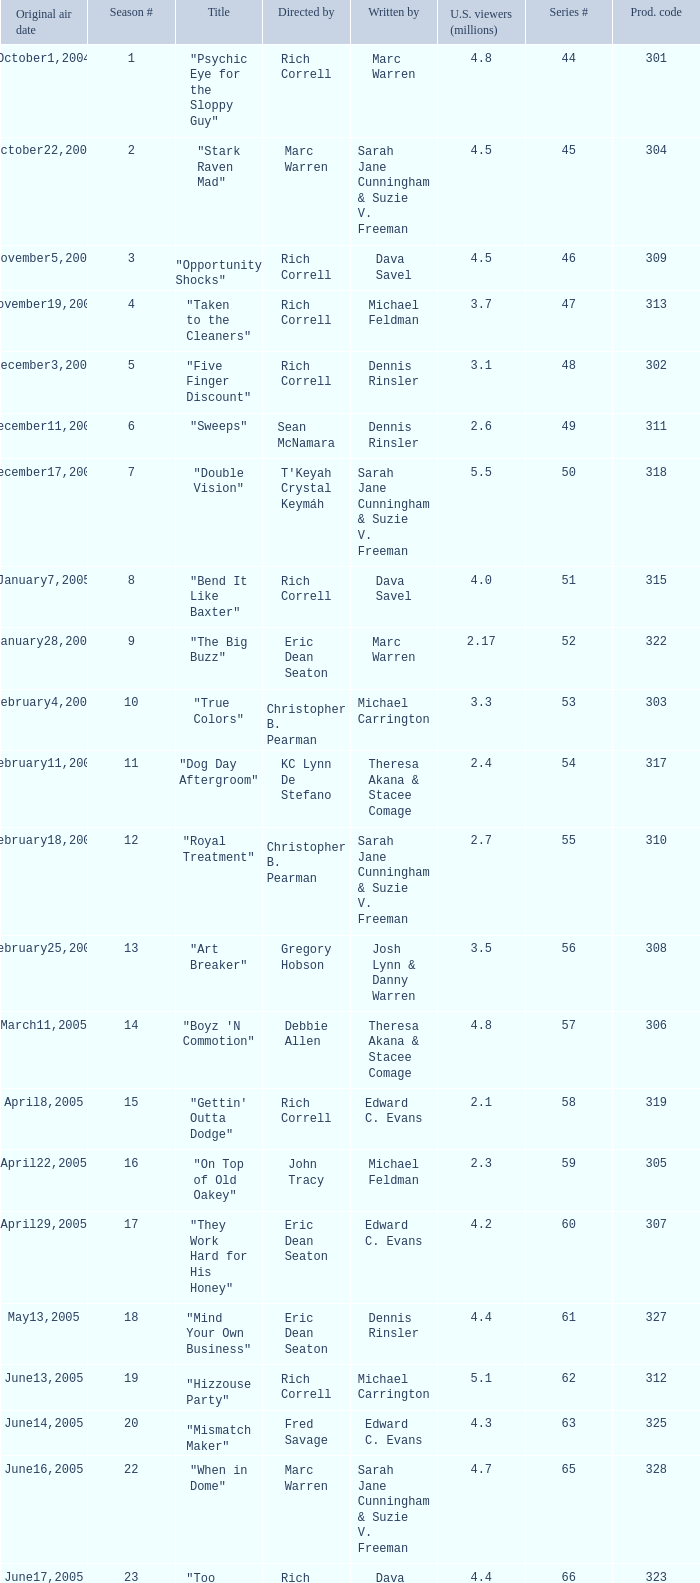What number episode of the season was titled "Vision Impossible"? 34.0. 